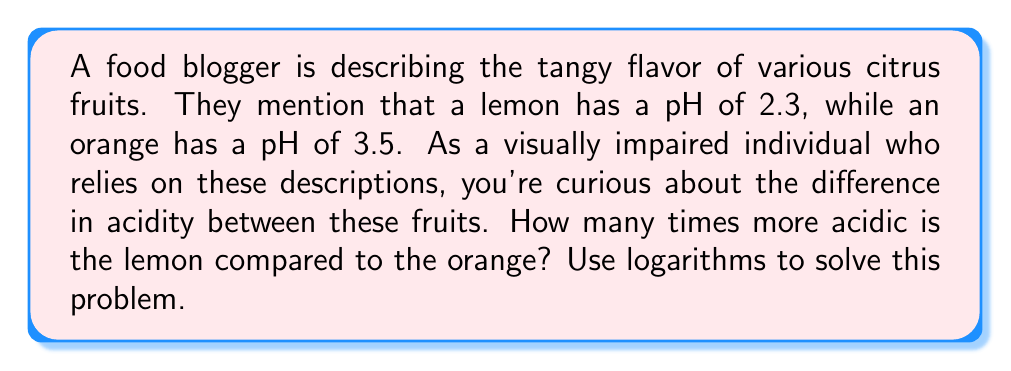Give your solution to this math problem. To solve this problem, we'll use the properties of logarithms and the definition of pH. Let's break it down step-by-step:

1) The pH scale is logarithmic and is defined as the negative logarithm (base 10) of the hydrogen ion concentration [H+]:

   $$ pH = -\log_{10}[H^+] $$

2) We can rearrange this equation to solve for [H+]:

   $$ [H^+] = 10^{-pH} $$

3) For the lemon (pH = 2.3):
   $$ [H^+]_{lemon} = 10^{-2.3} $$

4) For the orange (pH = 3.5):
   $$ [H^+]_{orange} = 10^{-3.5} $$

5) To find how many times more acidic the lemon is, we need to divide the lemon's [H+] by the orange's [H+]:

   $$ \frac{[H^+]_{lemon}}{[H^+]_{orange}} = \frac{10^{-2.3}}{10^{-3.5}} $$

6) Using the properties of exponents, we can simplify this:

   $$ \frac{10^{-2.3}}{10^{-3.5}} = 10^{-2.3 - (-3.5)} = 10^{-2.3 + 3.5} = 10^{1.2} $$

7) Now we can calculate this value:

   $$ 10^{1.2} \approx 15.85 $$

Therefore, the lemon is approximately 15.85 times more acidic than the orange.
Answer: The lemon is approximately 15.85 times more acidic than the orange. 